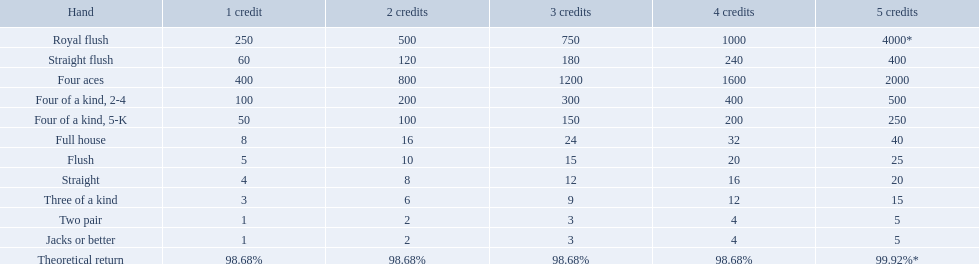Which hand is the third best hand in the card game super aces? Four aces. Which hand is the second best hand? Straight flush. Which hand had is the best hand? Royal flush. What is the values in the 5 credits area? 4000*, 400, 2000, 500, 250, 40, 25, 20, 15, 5, 5. Which of these is for a four of a kind? 500, 250. What is the higher value? 500. What hand is this for Four of a kind, 2-4. What are each of the hands? Royal flush, Straight flush, Four aces, Four of a kind, 2-4, Four of a kind, 5-K, Full house, Flush, Straight, Three of a kind, Two pair, Jacks or better, Theoretical return. Which hand ranks higher between straights and flushes? Flush. What are the different hands? Royal flush, Straight flush, Four aces, Four of a kind, 2-4, Four of a kind, 5-K, Full house, Flush, Straight, Three of a kind, Two pair, Jacks or better. Which hands have a higher standing than a straight? Royal flush, Straight flush, Four aces, Four of a kind, 2-4, Four of a kind, 5-K, Full house, Flush. Of these, which hand is the next highest after a straight? Flush. What does each hand contain? Royal flush, Straight flush, Four aces, Four of a kind, 2-4, Four of a kind, 5-K, Full house, Flush, Straight, Three of a kind, Two pair, Jacks or better, Theoretical return. Which hand is superior between straight and flush? Flush. What are the amounts in the 5 credits zone? 4000*, 400, 2000, 500, 250, 40, 25, 20, 15, 5, 5. Which one corresponds to a four of a kind? 500, 250. What is the greater amount? 500. For which hand is this designated? Four of a kind, 2-4. Which hand is the third top hand in the card game super aces? Four aces. Which hand is the second top hand? Straight flush. Which hand is the top hand? Royal flush. What are the hands in super aces? Royal flush, Straight flush, Four aces, Four of a kind, 2-4, Four of a kind, 5-K, Full house, Flush, Straight, Three of a kind, Two pair, Jacks or better. Which hand offers the highest rewards? Royal flush. What are the diverse hands? Royal flush, Straight flush, Four aces, Four of a kind, 2-4, Four of a kind, 5-K, Full house, Flush, Straight, Three of a kind, Two pair, Jacks or better. Which hands have a superior position than a straight? Royal flush, Straight flush, Four aces, Four of a kind, 2-4, Four of a kind, 5-K, Full house, Flush. Of these, which hand is the subsequent highest after a straight? Flush. What are the 5 top hand categories for triumph? Royal flush, Straight flush, Four aces, Four of a kind, 2-4, Four of a kind, 5-K. Among those 5, which of those hands consist of four of a kind? Four of a kind, 2-4, Four of a kind, 5-K. Of those 2 hands, which is the optimal type of four of a kind for success? Four of a kind, 2-4. What are the values within the 5-credit zone? 4000*, 400, 2000, 500, 250, 40, 25, 20, 15, 5, 5. Which one corresponds to a four of a kind? 500, 250. Which value is greater? 500. To which hand does this pertain? Four of a kind, 2-4. What poker hand is inferior to a straight flush? Four aces. What hand is inferior to four aces? Four of a kind, 2-4. Comparing a straight and a flush, which one has a superior ranking? Flush. 